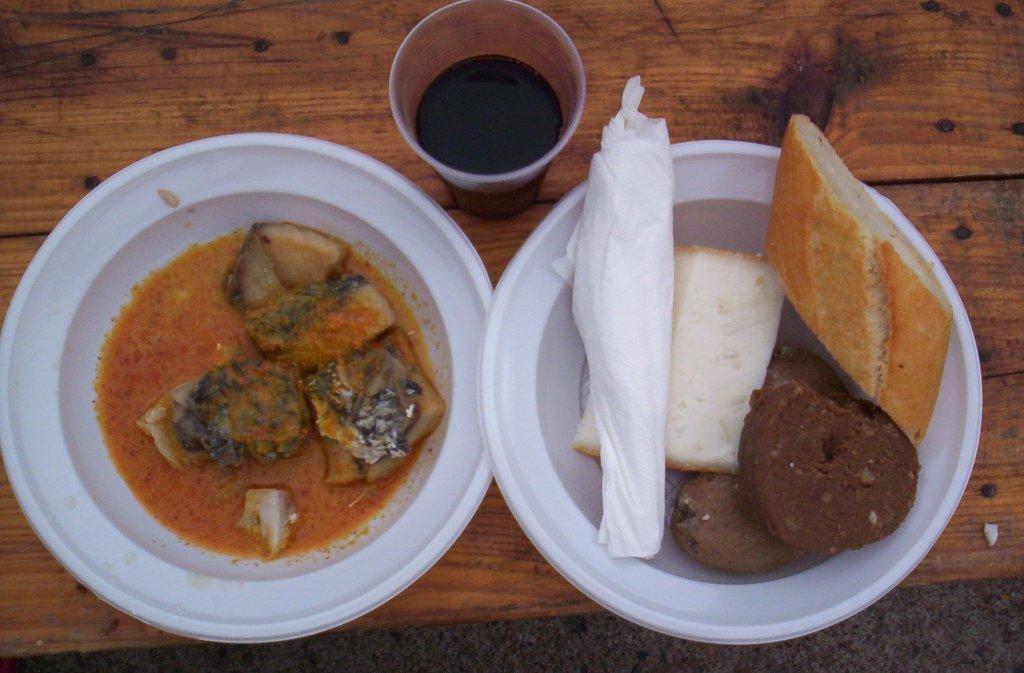Please provide a concise description of this image. In this image there is a table, on that table there are plates, in that plates there is a food item, beside the plate there is a glass, in that glass there is a liquid. 